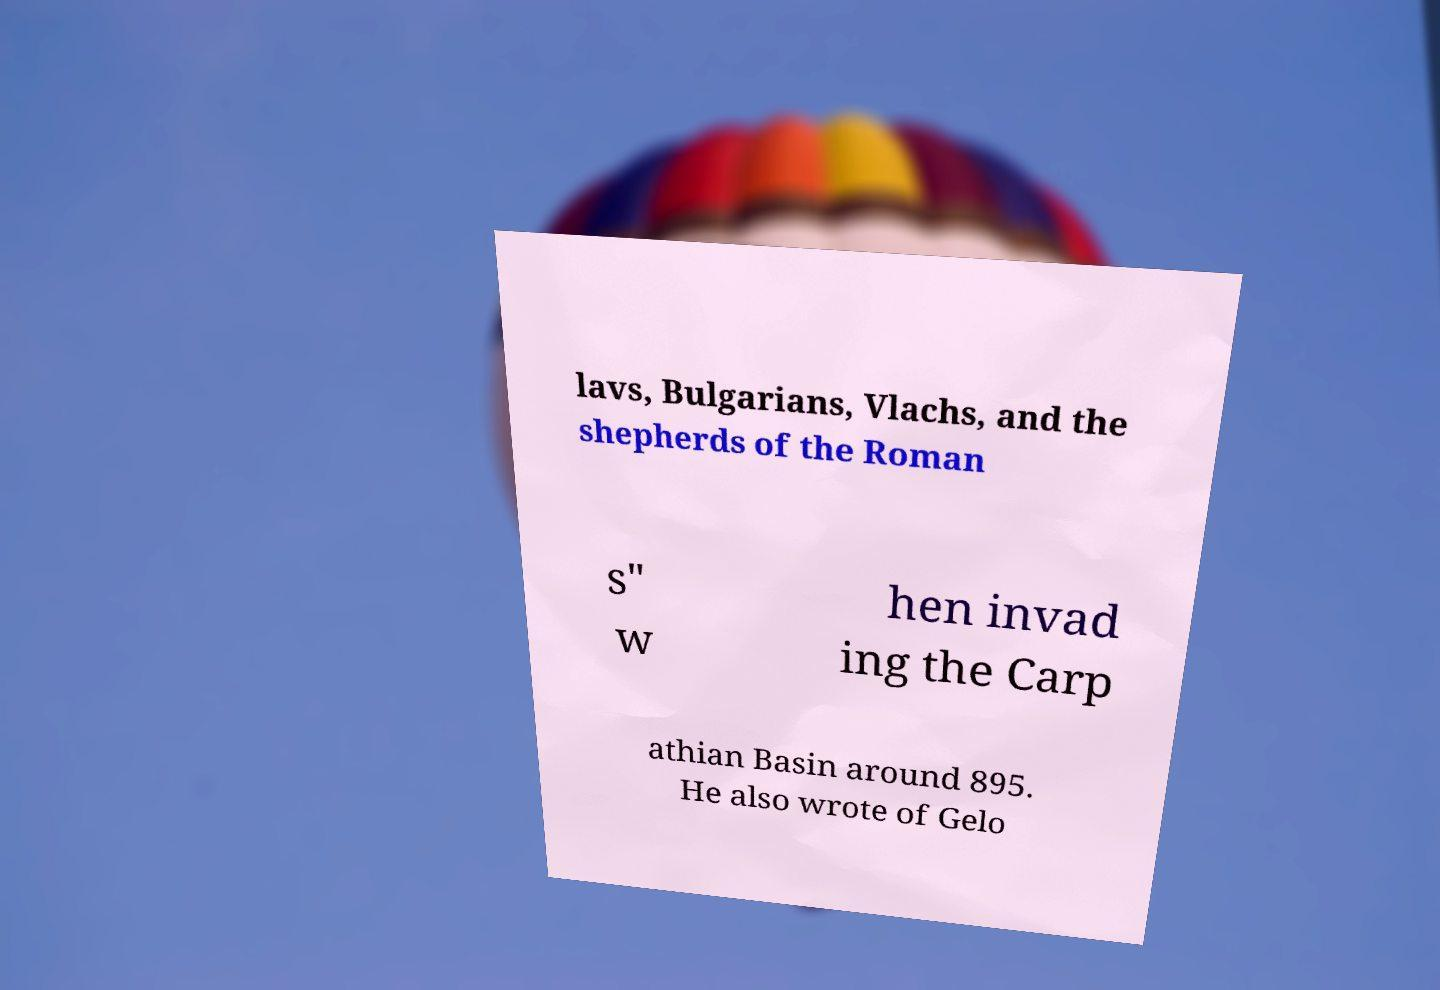There's text embedded in this image that I need extracted. Can you transcribe it verbatim? lavs, Bulgarians, Vlachs, and the shepherds of the Roman s" w hen invad ing the Carp athian Basin around 895. He also wrote of Gelo 